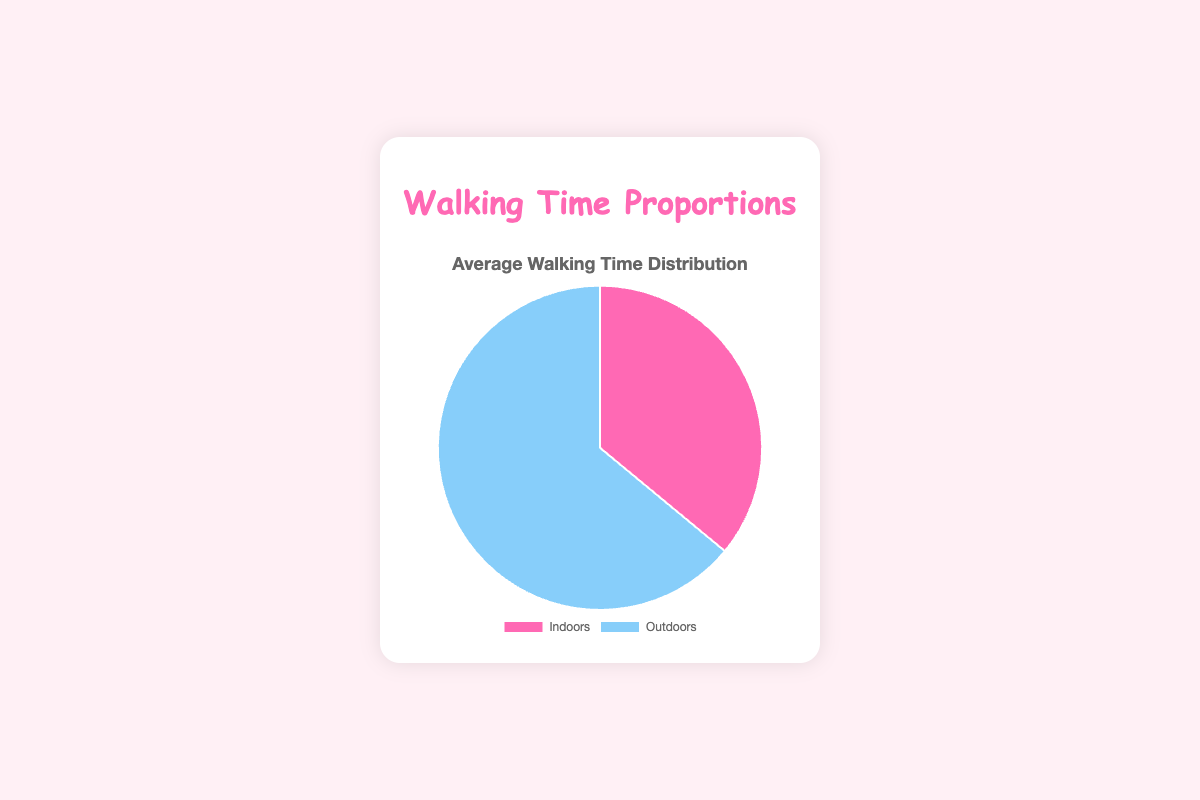What proportion of time is spent walking indoors for all users on average? The average proportion of time spent walking indoors is (30 + 40 + 25 + 50 + 35) / 5 = 180 / 5 = 36%
Answer: 36% Is the proportion of time spent walking outdoors greater than the time spent walking indoors on average? Yes, on average, users spend (64%) of their time walking outdoors compared to (36%) walking indoors.
Answer: Yes What is the total proportion of time spent walking both indoors and outdoors? The total proportion is 100% by definition, as it represents the complete distribution of time spent walking.
Answer: 100% Which user spends the highest proportion of time walking outdoors? By examining the proportions, Cara spends the most time walking outdoors at 75%.
Answer: Cara How does Diana's walking time distribution compare to the average distribution? Diana spends 50% of her walking time both indoors and outdoors, which is more balanced compared to the average distribution of 36% indoors and 64% outdoors.
Answer: More balanced What is the difference in proportion of time spent walking indoors between Alice and Eva? The difference is 35% (Eva) - 30% (Alice) = 5%
Answer: 5% How does Bella's proportion of time spent walking indoors compare to Cara's? Bella spends 40% of her time walking indoors, while Cara spends 25%, meaning Bella spends more time walking indoors than Cara by 15%.
Answer: More by 15% What is the ratio of the average time spent walking outdoors to indoors? The average time spent walking outdoors is 64%, and indoors is 36%. The ratio is 64:36, which simplifies to approximately 1.78:1.
Answer: 1.78:1 Which color represents the proportion of time spent walking indoors in the pie chart? The color representing the proportion of time spent walking indoors is pink.
Answer: Pink Is there any user who spends exactly the same proportion of time walking indoors and outdoors? Yes, Diana spends 50% of her walking time both indoors and outdoors.
Answer: Yes 